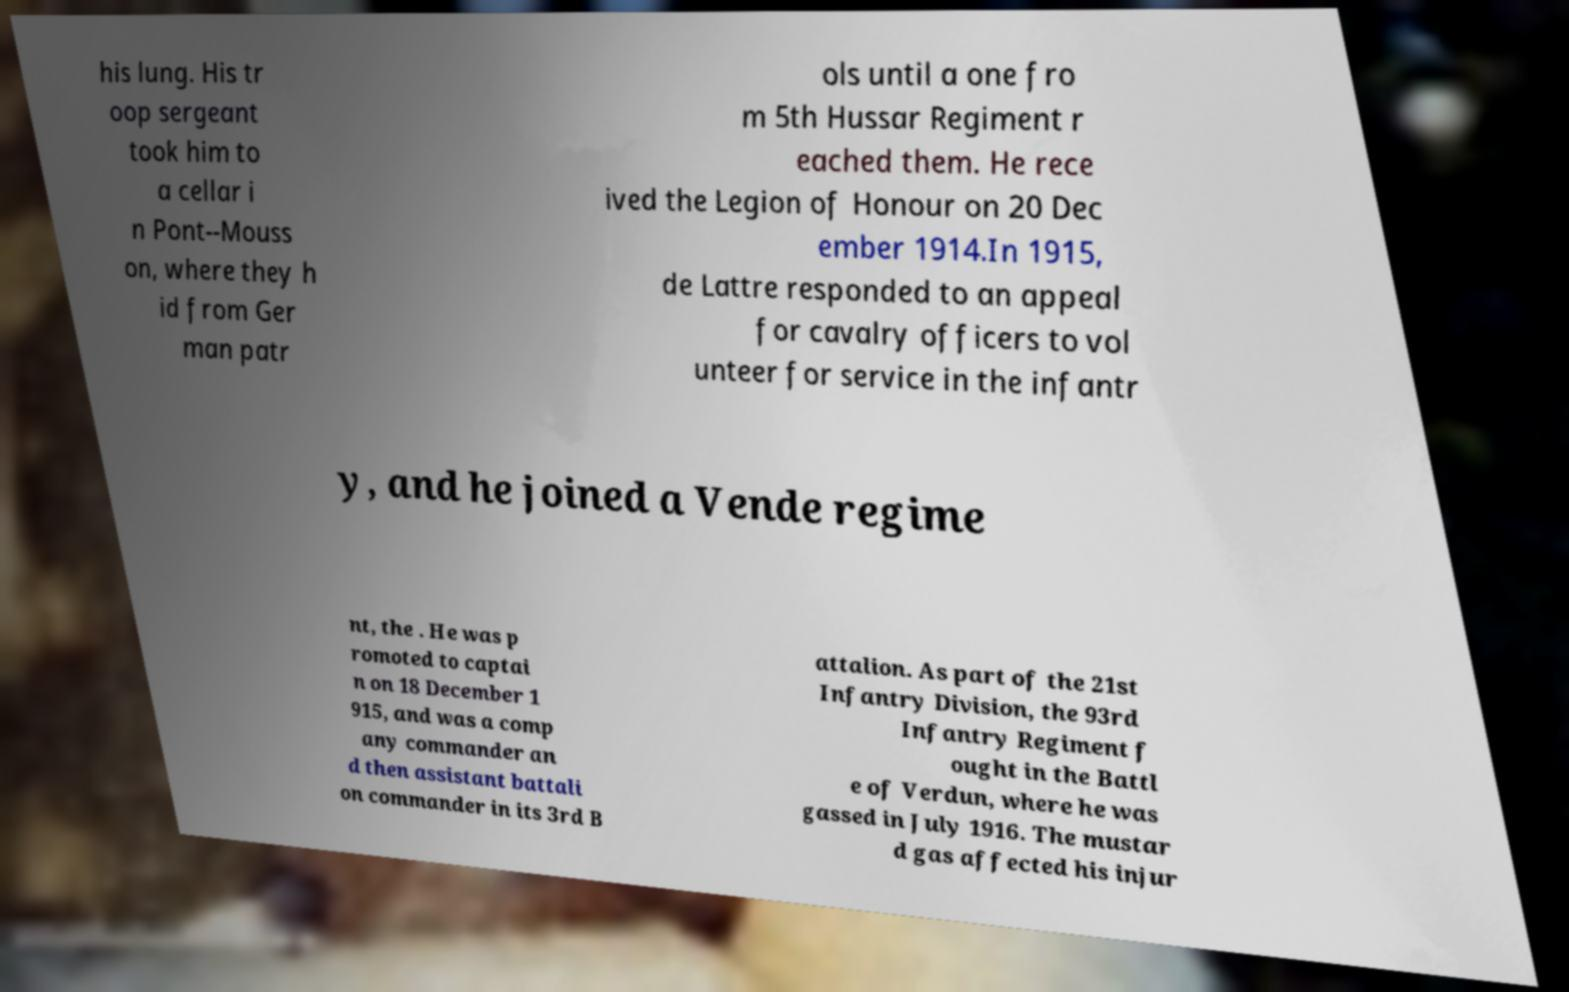There's text embedded in this image that I need extracted. Can you transcribe it verbatim? his lung. His tr oop sergeant took him to a cellar i n Pont--Mouss on, where they h id from Ger man patr ols until a one fro m 5th Hussar Regiment r eached them. He rece ived the Legion of Honour on 20 Dec ember 1914.In 1915, de Lattre responded to an appeal for cavalry officers to vol unteer for service in the infantr y, and he joined a Vende regime nt, the . He was p romoted to captai n on 18 December 1 915, and was a comp any commander an d then assistant battali on commander in its 3rd B attalion. As part of the 21st Infantry Division, the 93rd Infantry Regiment f ought in the Battl e of Verdun, where he was gassed in July 1916. The mustar d gas affected his injur 